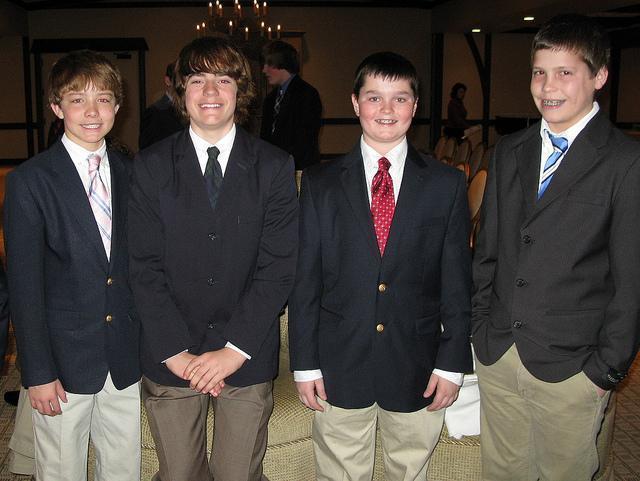How many ties are there?
Give a very brief answer. 4. How many people are there?
Give a very brief answer. 6. How many of the train cars are yellow and red?
Give a very brief answer. 0. 